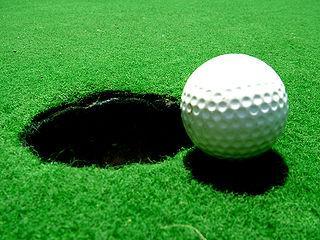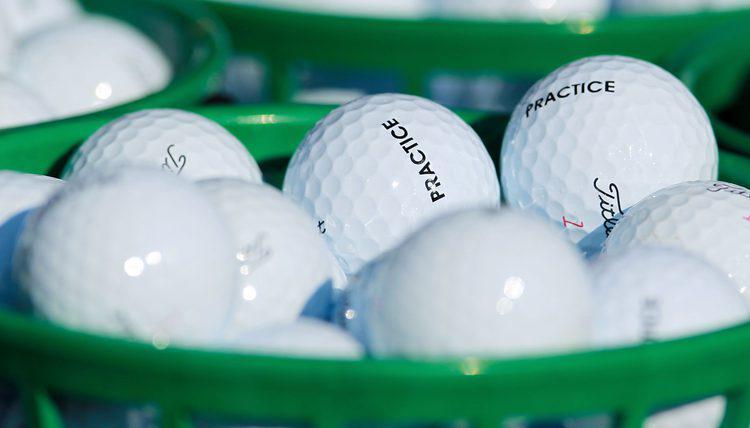The first image is the image on the left, the second image is the image on the right. For the images displayed, is the sentence "An image shows a green container filled with only white golf balls." factually correct? Answer yes or no. Yes. The first image is the image on the left, the second image is the image on the right. Examine the images to the left and right. Is the description "The balls in the image on the right are sitting in a green basket." accurate? Answer yes or no. Yes. 